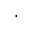Convert formula to latex. <formula><loc_0><loc_0><loc_500><loc_500>\cdot</formula> 